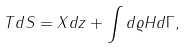Convert formula to latex. <formula><loc_0><loc_0><loc_500><loc_500>T d S = X d z + \int d \varrho H d \Gamma ,</formula> 